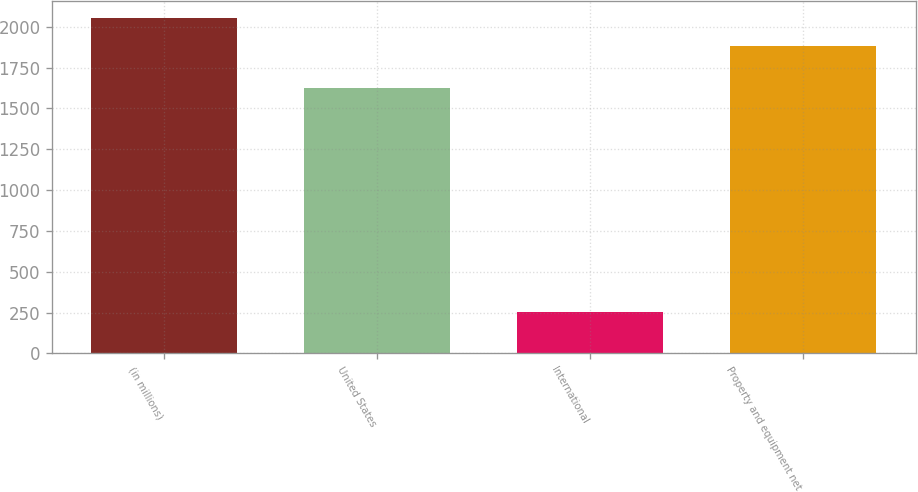Convert chart. <chart><loc_0><loc_0><loc_500><loc_500><bar_chart><fcel>(in millions)<fcel>United States<fcel>International<fcel>Property and equipment net<nl><fcel>2055.1<fcel>1623<fcel>256<fcel>1879<nl></chart> 